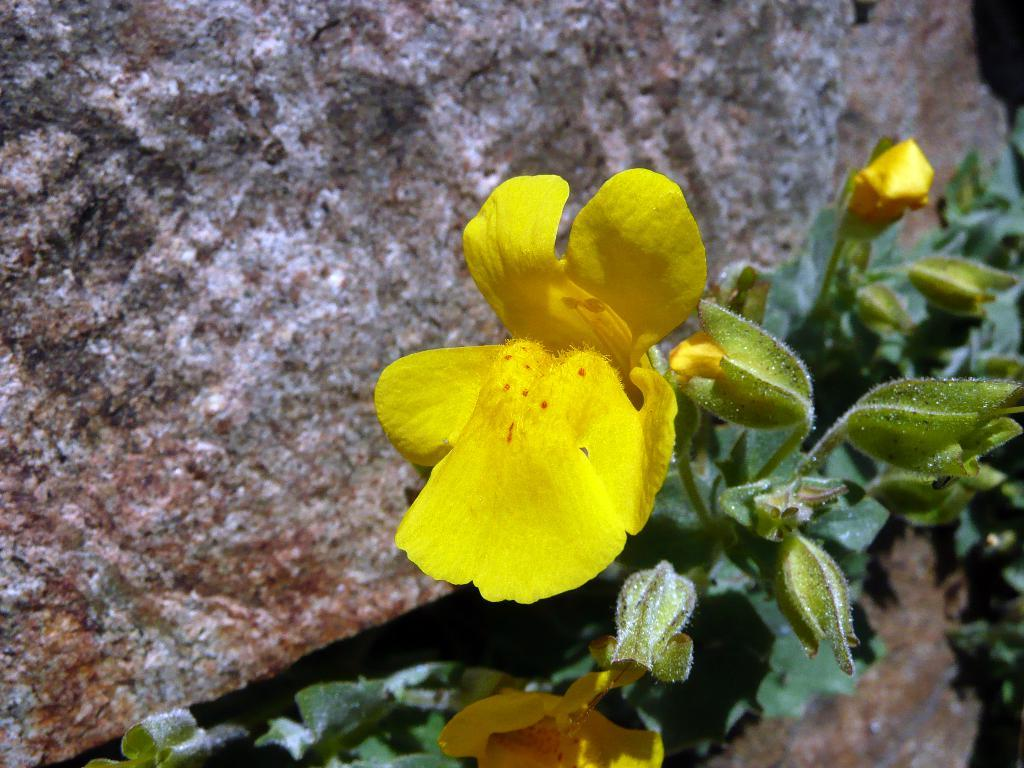What type of living organisms are present in the image? There are plants in the image. What color are the flowers on the plants? The flowers on the plants are yellow. Are there any unopened flowers on the plants? Yes, the plants have buds. What is located on the left side of the flowers? There is a rock on the left side of the flowers. Can you describe the volcano erupting in the background of the image? There is no volcano present in the image; it features plants with yellow flowers and a rock on the left side. 